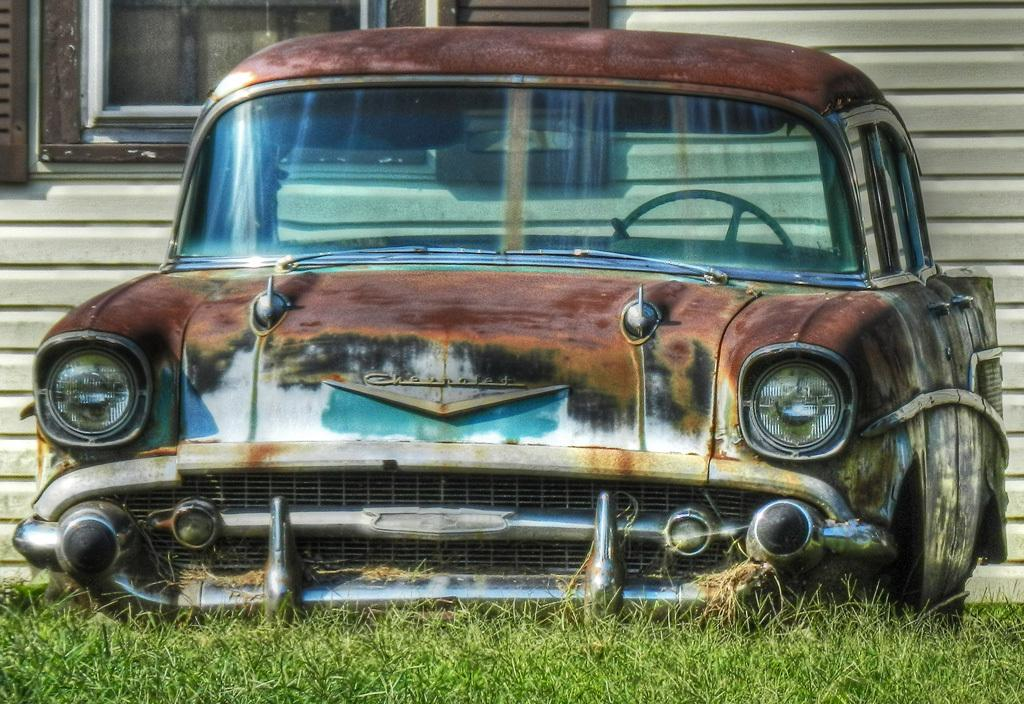What is the main subject in the center of the image? There is an old rusted car in the center of the image. What type of vegetation is visible at the bottom of the image? There is grass at the bottom of the image. What can be seen in the background of the image? There is a wall and a window in the background of the image. What type of zipper can be seen on the car in the image? There is no zipper present on the car in the image; it is an old rusted car. Is there a gate visible in the image? There is no gate present in the image. 